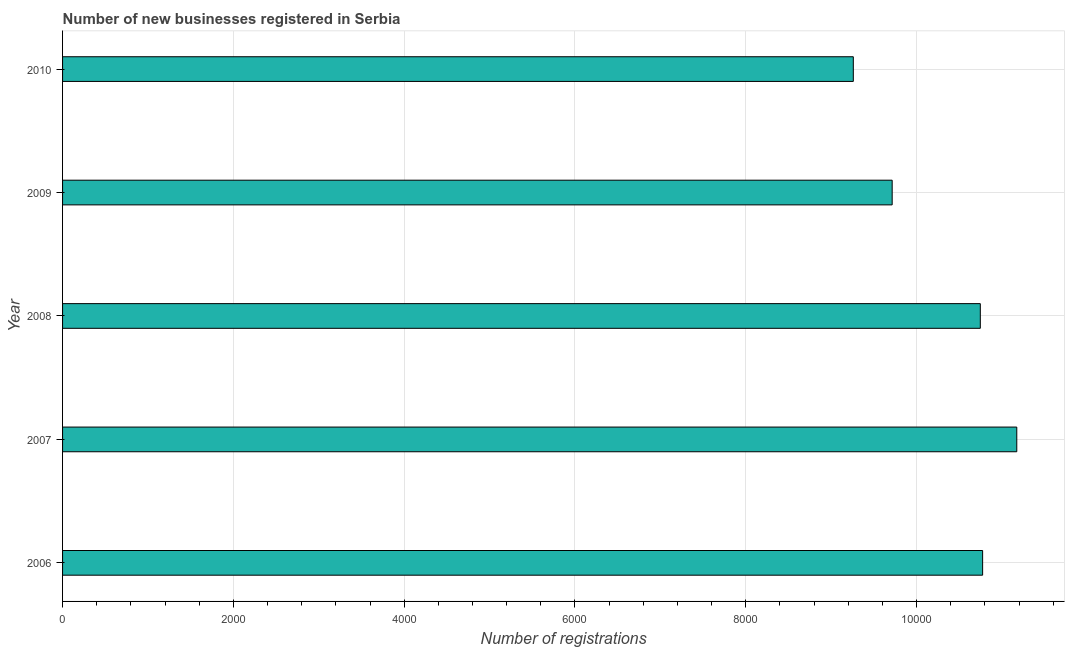Does the graph contain grids?
Your answer should be very brief. Yes. What is the title of the graph?
Give a very brief answer. Number of new businesses registered in Serbia. What is the label or title of the X-axis?
Provide a succinct answer. Number of registrations. What is the label or title of the Y-axis?
Ensure brevity in your answer.  Year. What is the number of new business registrations in 2006?
Offer a very short reply. 1.08e+04. Across all years, what is the maximum number of new business registrations?
Make the answer very short. 1.12e+04. Across all years, what is the minimum number of new business registrations?
Keep it short and to the point. 9259. In which year was the number of new business registrations maximum?
Your answer should be very brief. 2007. In which year was the number of new business registrations minimum?
Offer a terse response. 2010. What is the sum of the number of new business registrations?
Ensure brevity in your answer.  5.17e+04. What is the difference between the number of new business registrations in 2007 and 2009?
Make the answer very short. 1459. What is the average number of new business registrations per year?
Ensure brevity in your answer.  1.03e+04. What is the median number of new business registrations?
Make the answer very short. 1.07e+04. Is the number of new business registrations in 2007 less than that in 2008?
Keep it short and to the point. No. Is the difference between the number of new business registrations in 2008 and 2010 greater than the difference between any two years?
Make the answer very short. No. What is the difference between the highest and the lowest number of new business registrations?
Give a very brief answer. 1914. In how many years, is the number of new business registrations greater than the average number of new business registrations taken over all years?
Ensure brevity in your answer.  3. Are all the bars in the graph horizontal?
Your answer should be compact. Yes. How many years are there in the graph?
Offer a very short reply. 5. What is the difference between two consecutive major ticks on the X-axis?
Your response must be concise. 2000. What is the Number of registrations of 2006?
Make the answer very short. 1.08e+04. What is the Number of registrations in 2007?
Provide a succinct answer. 1.12e+04. What is the Number of registrations in 2008?
Your answer should be very brief. 1.07e+04. What is the Number of registrations of 2009?
Keep it short and to the point. 9714. What is the Number of registrations in 2010?
Your answer should be very brief. 9259. What is the difference between the Number of registrations in 2006 and 2007?
Your answer should be compact. -400. What is the difference between the Number of registrations in 2006 and 2009?
Make the answer very short. 1059. What is the difference between the Number of registrations in 2006 and 2010?
Offer a terse response. 1514. What is the difference between the Number of registrations in 2007 and 2008?
Provide a short and direct response. 427. What is the difference between the Number of registrations in 2007 and 2009?
Your response must be concise. 1459. What is the difference between the Number of registrations in 2007 and 2010?
Your answer should be compact. 1914. What is the difference between the Number of registrations in 2008 and 2009?
Make the answer very short. 1032. What is the difference between the Number of registrations in 2008 and 2010?
Your answer should be compact. 1487. What is the difference between the Number of registrations in 2009 and 2010?
Make the answer very short. 455. What is the ratio of the Number of registrations in 2006 to that in 2009?
Offer a terse response. 1.11. What is the ratio of the Number of registrations in 2006 to that in 2010?
Provide a short and direct response. 1.16. What is the ratio of the Number of registrations in 2007 to that in 2008?
Offer a very short reply. 1.04. What is the ratio of the Number of registrations in 2007 to that in 2009?
Make the answer very short. 1.15. What is the ratio of the Number of registrations in 2007 to that in 2010?
Your answer should be very brief. 1.21. What is the ratio of the Number of registrations in 2008 to that in 2009?
Make the answer very short. 1.11. What is the ratio of the Number of registrations in 2008 to that in 2010?
Provide a succinct answer. 1.16. What is the ratio of the Number of registrations in 2009 to that in 2010?
Ensure brevity in your answer.  1.05. 